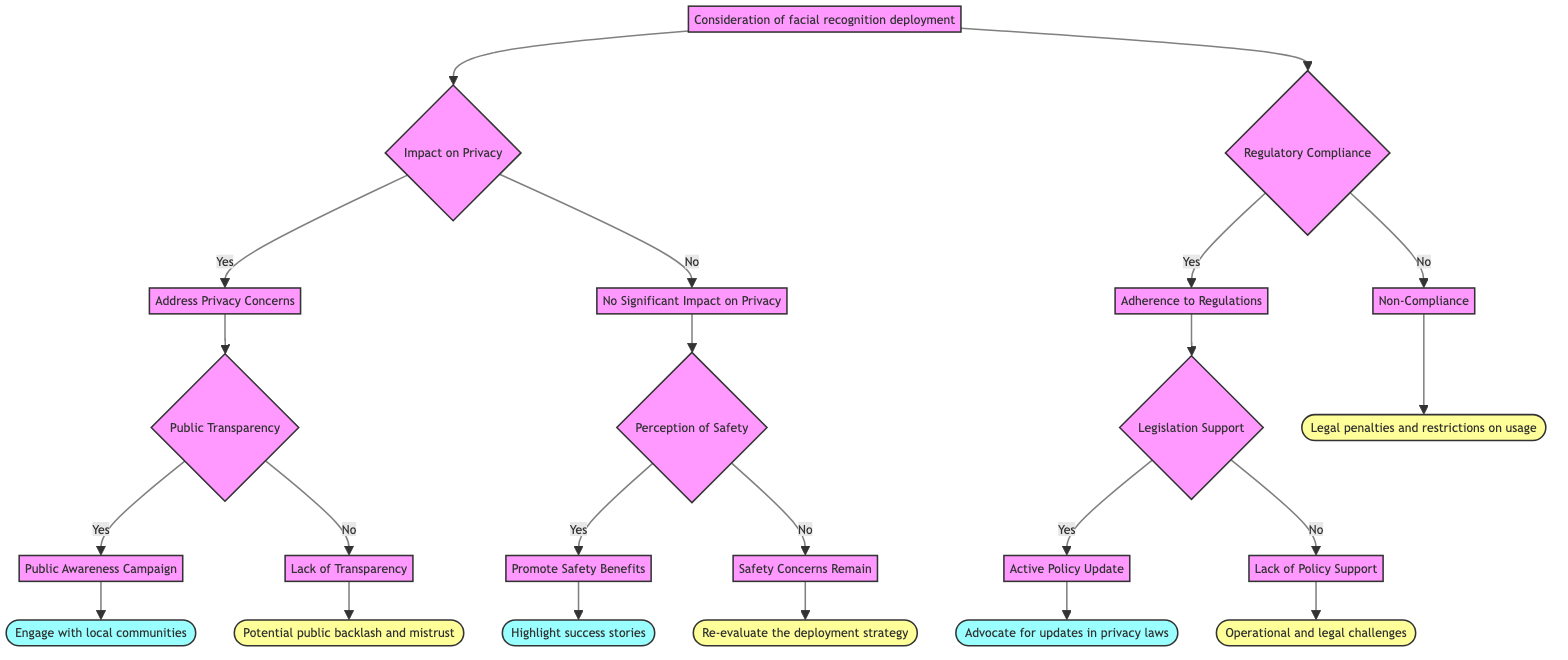What is the starting point of the decision tree? The starting point is labeled as "Consideration of facial recognition deployment." It is the first node from which all branching decisions begin.
Answer: Consideration of facial recognition deployment How many outcomes are there under the 'Impact on Privacy' decision? The 'Impact on Privacy' node branches into two outcomes: 'Yes' and 'No', thus there are two outcomes.
Answer: 2 What action follows a 'Yes' answer to 'Public Transparency'? Following a 'Yes' to 'Public Transparency', the next action is 'Public Awareness Campaign'. This indicates a proactive approach to informing the community.
Answer: Public Awareness Campaign What is the consequence of 'Lack of Transparency'? The consequence of 'Lack of Transparency' is 'Potential public backlash and mistrust'. This suggests that failing to be transparent can lead to distrust from the public.
Answer: Potential public backlash and mistrust If there is 'Non-Compliance', what legal outcome is indicated? The diagram indicates that 'Non-Compliance' leads to 'Legal penalties and restrictions on usage', highlighting the legal ramifications of not adhering to regulations.
Answer: Legal penalties and restrictions on usage What decision follows the 'No' outcome under 'Regulatory Compliance'? The 'No' outcome under 'Regulatory Compliance' leads to 'Non-Compliance', which signifies a failure to comply with regulations.
Answer: Non-Compliance What is the action if there is 'Legislation Support'? If there is 'Legislation Support', the action that follows is 'Active Policy Update', which implies that there is a positive movement towards updating policies.
Answer: Active Policy Update What happens if 'Safety Concerns Remain'? If 'Safety Concerns Remain', the consequence is to 'Re-evaluate the deployment strategy', indicating a need to reconsider the deployment process.
Answer: Re-evaluate the deployment strategy Which node leads to the 'Advocate for updates in privacy laws' action? The node leading to 'Advocate for updates in privacy laws' is 'Active Policy Update', which follows 'Legislation Support' under 'Adherence to Regulations'.
Answer: Active Policy Update 